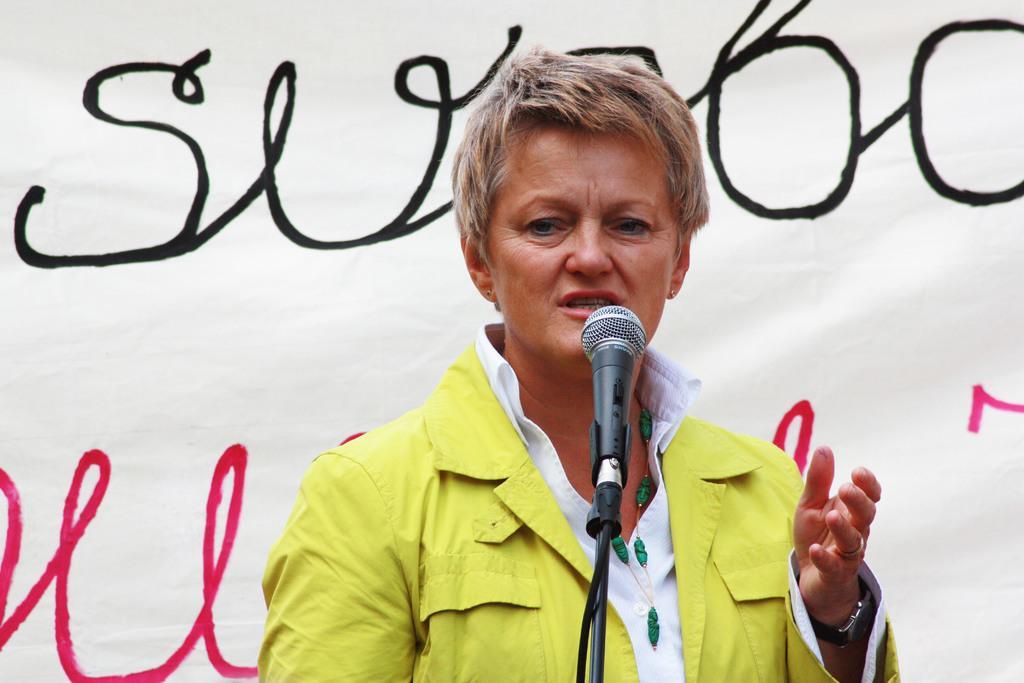How would you summarize this image in a sentence or two? In the picture I can see one person is taking in front of the microphone, behind we can see one banner. 